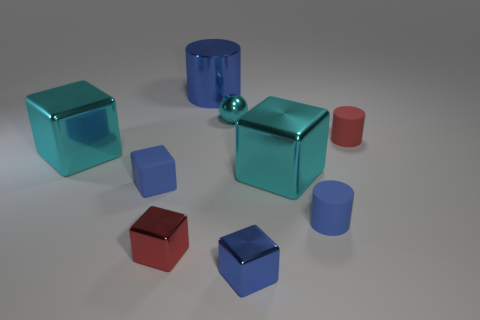There is a tiny red rubber cylinder; what number of blue metal cylinders are in front of it? 0 